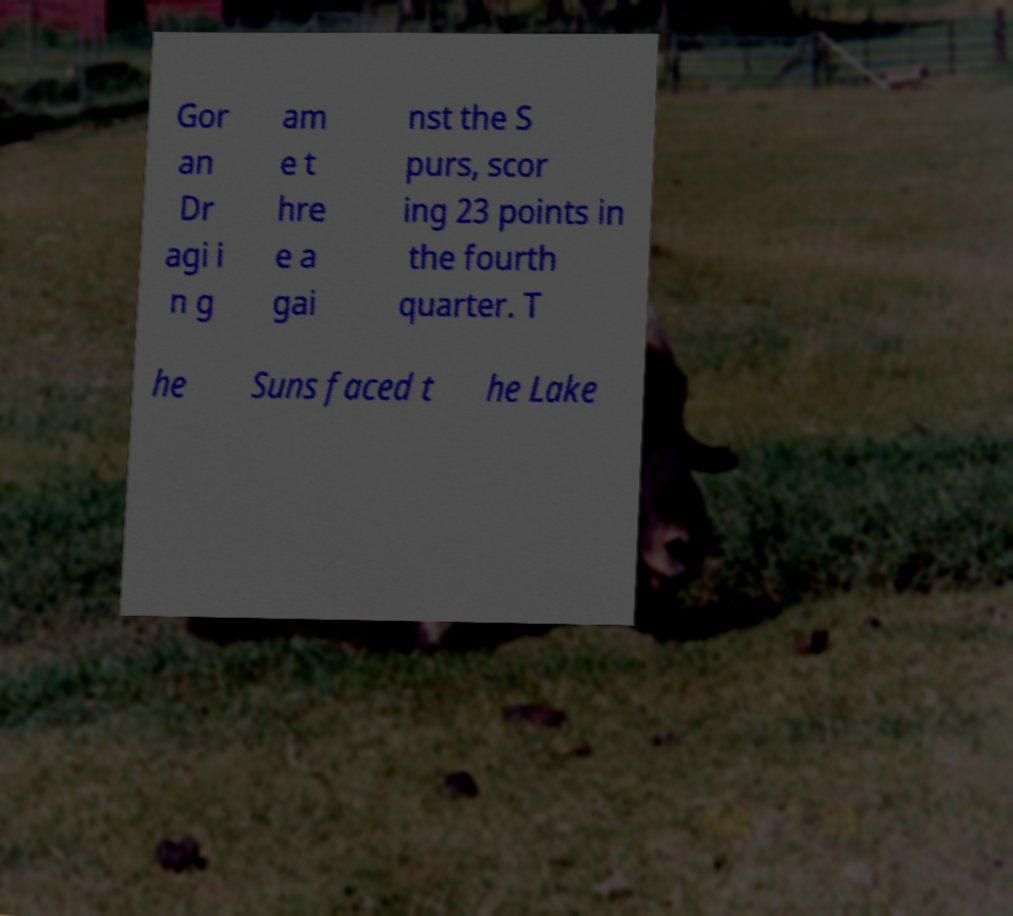For documentation purposes, I need the text within this image transcribed. Could you provide that? Gor an Dr agi i n g am e t hre e a gai nst the S purs, scor ing 23 points in the fourth quarter. T he Suns faced t he Lake 